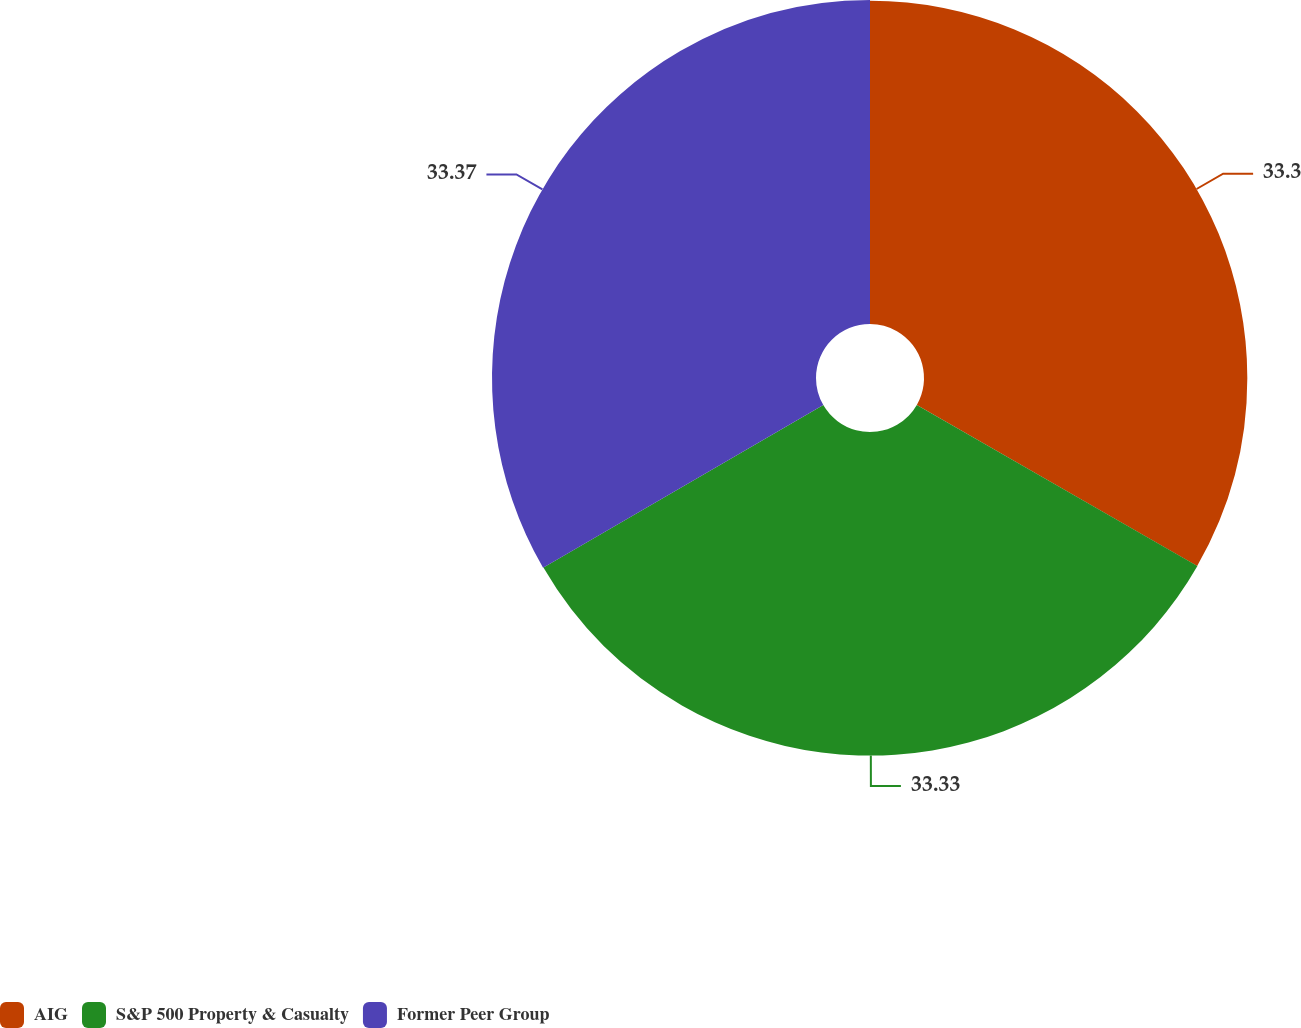Convert chart. <chart><loc_0><loc_0><loc_500><loc_500><pie_chart><fcel>AIG<fcel>S&P 500 Property & Casualty<fcel>Former Peer Group<nl><fcel>33.3%<fcel>33.33%<fcel>33.37%<nl></chart> 